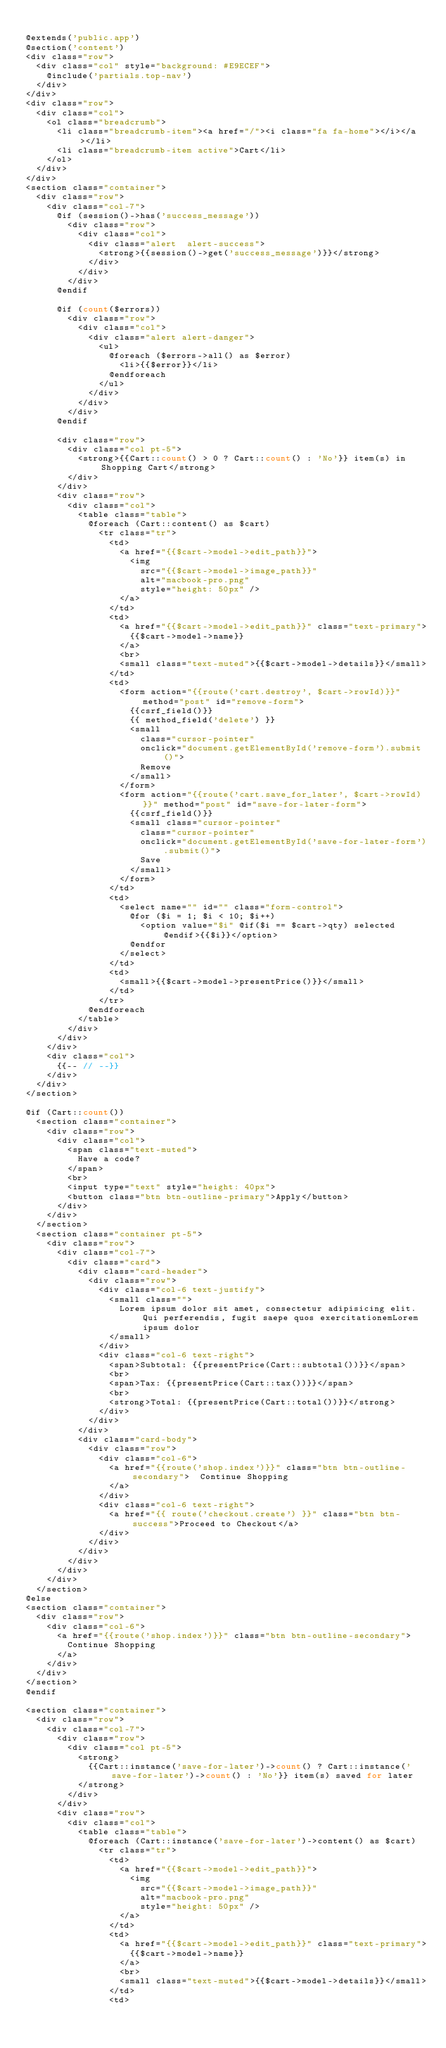<code> <loc_0><loc_0><loc_500><loc_500><_PHP_>
@extends('public.app')
@section('content')
<div class="row">
	<div class="col" style="background: #E9ECEF">
		@include('partials.top-nav')
	</div>
</div>
<div class="row">
	<div class="col">
		<ol class="breadcrumb">
		  <li class="breadcrumb-item"><a href="/"><i class="fa fa-home"></i></a></li>
		  <li class="breadcrumb-item active">Cart</li>
		</ol>
	</div>
</div>
<section class="container">
	<div class="row">
		<div class="col-7">
			@if (session()->has('success_message'))
				<div class="row">
					<div class="col">
						<div class="alert  alert-success">
							<strong>{{session()->get('success_message')}}</strong>
						</div>
					</div>
				</div>
			@endif

			@if (count($errors))
				<div class="row">
					<div class="col">
						<div class="alert alert-danger">
							<ul>
								@foreach ($errors->all() as $error)
									<li>{{$error}}</li>
								@endforeach
							</ul>
						</div>
					</div>
				</div>
			@endif

			<div class="row">
				<div class="col pt-5">
					<strong>{{Cart::count() > 0 ? Cart::count() : 'No'}} item(s) in Shopping Cart</strong>
				</div>
			</div>
			<div class="row">
				<div class="col">
					<table class="table">
						@foreach (Cart::content() as $cart)
							<tr class="tr">
								<td>
									<a href="{{$cart->model->edit_path}}">	
										<img 
											src="{{$cart->model->image_path}}"
											alt="macbook-pro.png" 
											style="height: 50px" />
									</a>
								</td>
								<td>
									<a href="{{$cart->model->edit_path}}" class="text-primary">
										{{$cart->model->name}}
									</a>
									<br>
									<small class="text-muted">{{$cart->model->details}}</small>
								</td>
								<td>
									<form action="{{route('cart.destroy', $cart->rowId)}}" method="post" id="remove-form">
										{{csrf_field()}}
										{{ method_field('delete') }}
										<small
											class="cursor-pointer" 
											onclick="document.getElementById('remove-form').submit()">
											Remove
										</small>
									</form>
									<form action="{{route('cart.save_for_later', $cart->rowId)}}" method="post" id="save-for-later-form">
										{{csrf_field()}}
										<small class="cursor-pointer" 
											class="cursor-pointer" 
											onclick="document.getElementById('save-for-later-form').submit()">
											Save
										</small>
									</form>
								</td>
								<td>
									<select name="" id="" class="form-control">
										@for ($i = 1; $i < 10; $i++)
											<option value="$i" @if($i == $cart->qty) selected @endif>{{$i}}</option>
										@endfor
									</select>
								</td>
								<td>
									<small>{{$cart->model->presentPrice()}}</small>
								</td>
							</tr>
						@endforeach
					</table>
				</div>
			</div>
		</div>
		<div class="col">
			{{-- // --}}
		</div>
	</div>
</section>

@if (Cart::count())
	<section class="container">
		<div class="row">
			<div class="col">
				<span class="text-muted">
					Have a code?
				</span>
				<br>
				<input type="text" style="height: 40px">
				<button class="btn btn-outline-primary">Apply</button>
			</div>
		</div>
	</section>
	<section class="container pt-5">
		<div class="row">
			<div class="col-7">
				<div class="card">
					<div class="card-header">
						<div class="row">
							<div class="col-6 text-justify">
								<small class="">
									Lorem ipsum dolor sit amet, consectetur adipisicing elit. Qui perferendis, fugit saepe quos exercitationemLorem ipsum dolor
								</small>
							</div>
							<div class="col-6 text-right">
								<span>Subtotal: {{presentPrice(Cart::subtotal())}}</span>
								<br>
								<span>Tax: {{presentPrice(Cart::tax())}}</span>
								<br>
								<strong>Total: {{presentPrice(Cart::total())}}</strong>
							</div>
						</div>
					</div>
					<div class="card-body">
						<div class="row">
							<div class="col-6">
								<a href="{{route('shop.index')}}" class="btn btn-outline-secondary">	Continue Shopping
								</a>
							</div>
							<div class="col-6 text-right">
								<a href="{{ route('checkout.create') }}" class="btn btn-success">Proceed to Checkout</a>
							</div>
						</div>
					</div>
				</div>
			</div>
		</div>	
	</section>
@else
<section class="container">
	<div class="row">
		<div class="col-6">
			<a href="{{route('shop.index')}}" class="btn btn-outline-secondary">
				Continue Shopping
			</a>
		</div>
	</div>
</section>
@endif

<section class="container">
	<div class="row">
		<div class="col-7">
			<div class="row">
				<div class="col pt-5">
					<strong>
						{{Cart::instance('save-for-later')->count() ? Cart::instance('save-for-later')->count() : 'No'}} item(s) saved for later
					</strong>
				</div>
			</div>
			<div class="row">
				<div class="col">
					<table class="table">
						@foreach (Cart::instance('save-for-later')->content() as $cart)
							<tr class="tr">
								<td>
									<a href="{{$cart->model->edit_path}}">	
										<img 
											src="{{$cart->model->image_path}}"
											alt="macbook-pro.png" 
											style="height: 50px" />
									</a>
								</td>
								<td>
									<a href="{{$cart->model->edit_path}}" class="text-primary">
										{{$cart->model->name}}
									</a>
									<br>
									<small class="text-muted">{{$cart->model->details}}</small>
								</td>
								<td></code> 